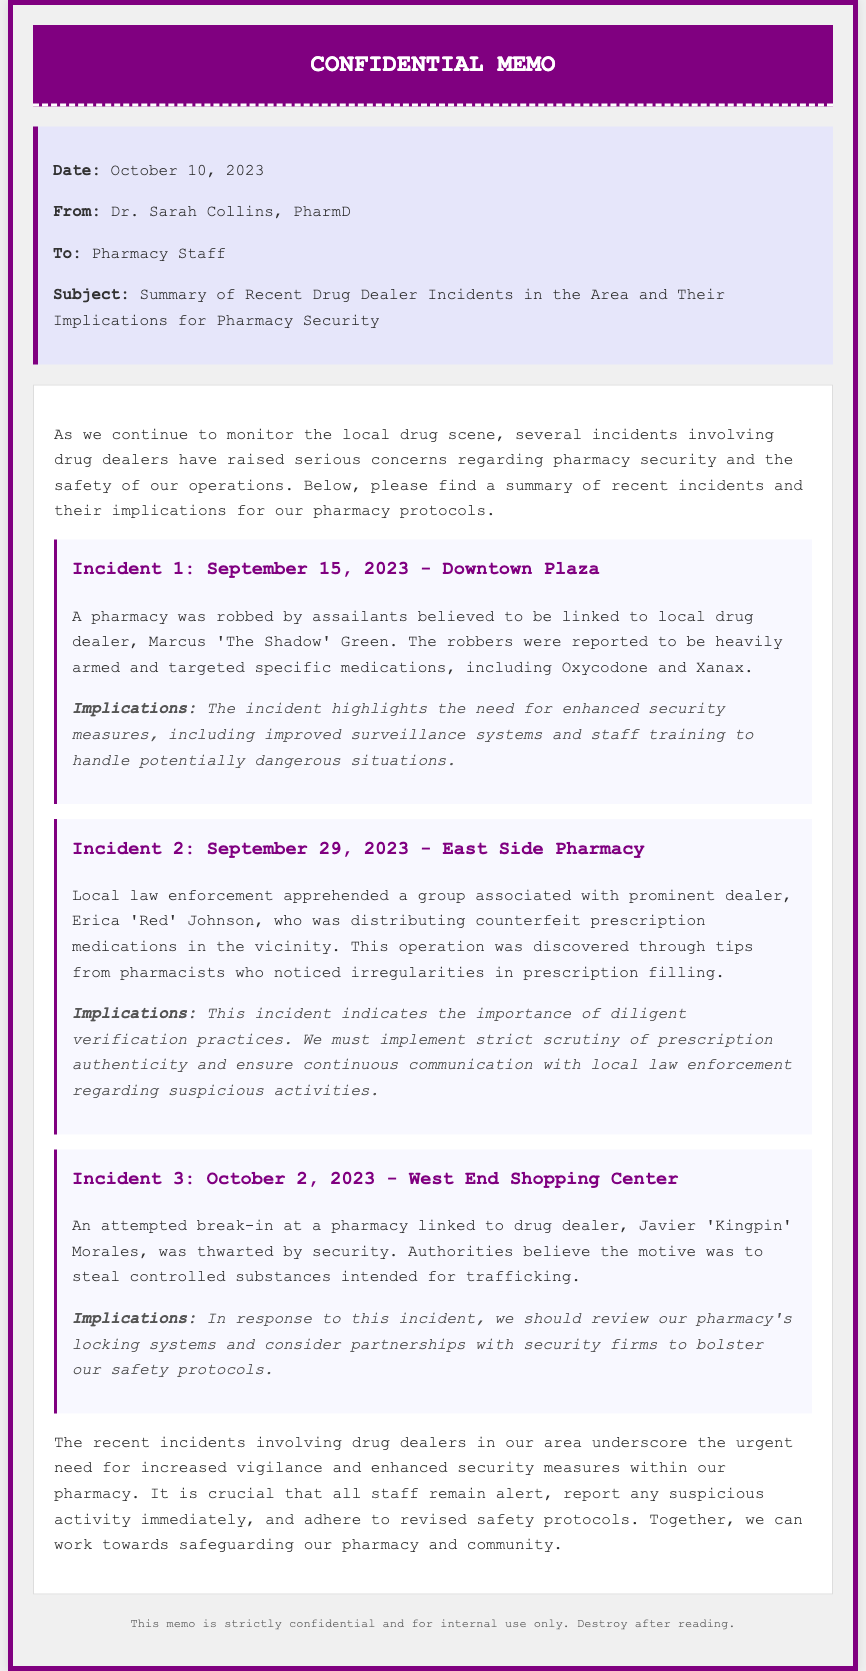What is the date of the memo? The date of the memo is clearly stated at the beginning of the document.
Answer: October 10, 2023 Who is the author of the memo? The author of the memo is listed in the memo info section.
Answer: Dr. Sarah Collins, PharmD What was targeted in the Downtown Plaza incident? The memo provides details about specific medications targeted during the incident.
Answer: Oxycodone and Xanax What was the name of the dealer involved in the second incident? The memo mentions the drug dealer associated with the East Side Pharmacy incident.
Answer: Erica 'Red' Johnson What security measure is suggested after the October 2 incident? The memo lists implications that arise from each incident, including security measures.
Answer: Review locking systems How many incidents are summarized in this memo? The memo summarizes three distinct incidents involving drug dealers.
Answer: Three What is the main concern highlighted in the memo? The memo addresses the overarching issue that arises from the incidents described.
Answer: Pharmacy security What is advised for pharmacy staff regarding suspicious activity? The memo includes a call to action for pharmacy staff regarding their response to suspicious actions.
Answer: Report immediately 